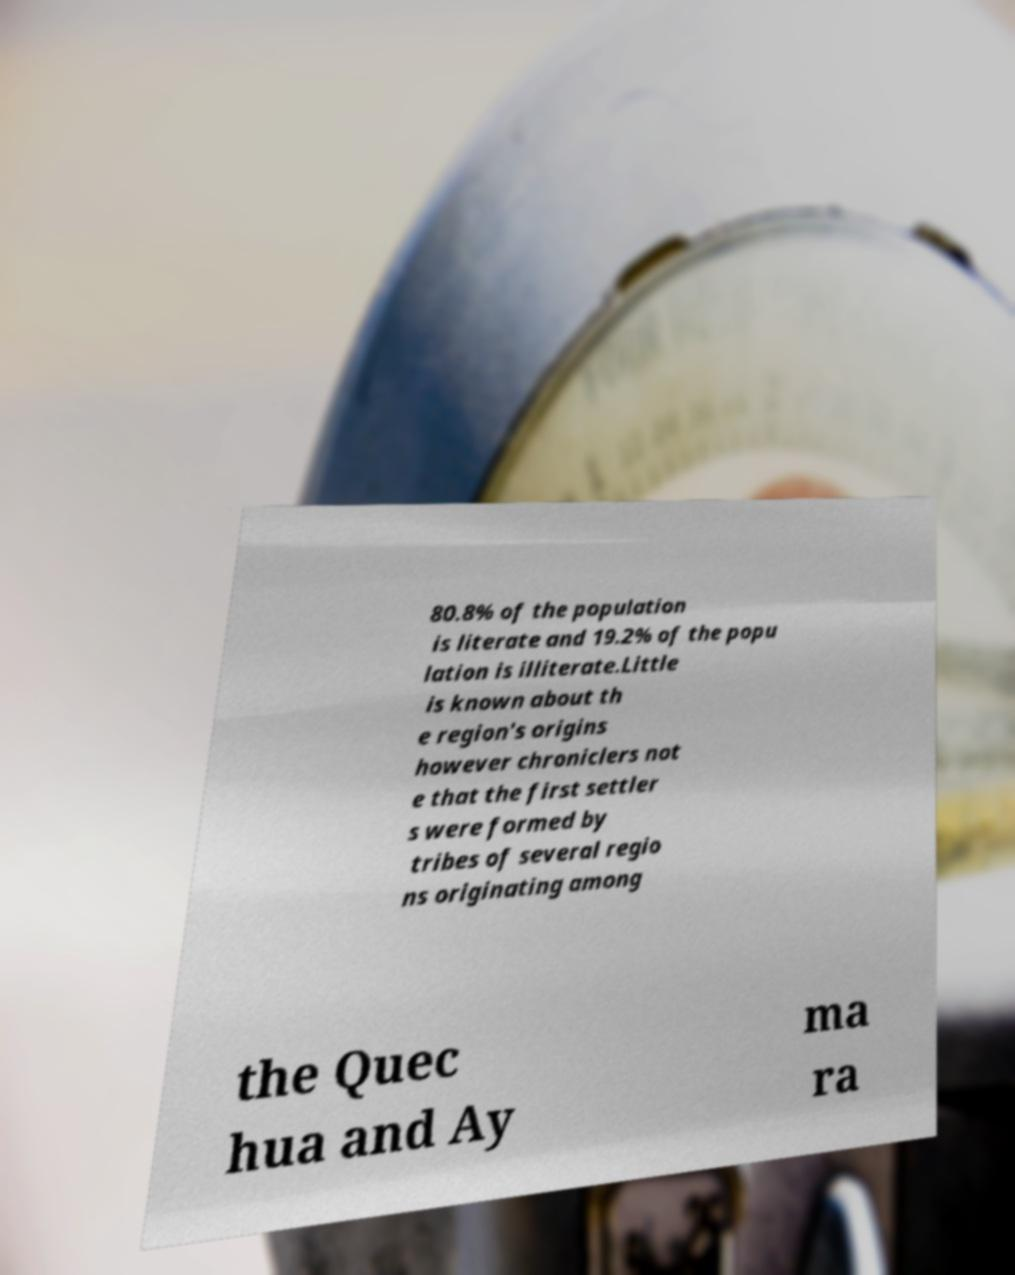Could you extract and type out the text from this image? 80.8% of the population is literate and 19.2% of the popu lation is illiterate.Little is known about th e region's origins however chroniclers not e that the first settler s were formed by tribes of several regio ns originating among the Quec hua and Ay ma ra 